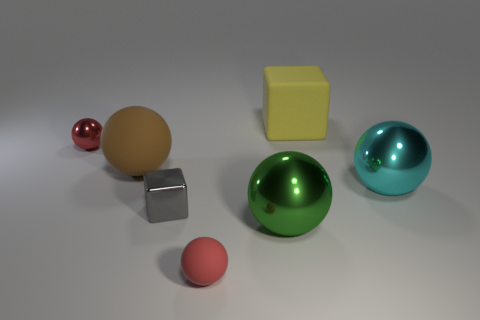Subtract all small metal spheres. How many spheres are left? 4 Subtract all yellow spheres. Subtract all blue cylinders. How many spheres are left? 5 Add 2 gray things. How many objects exist? 9 Subtract all cubes. How many objects are left? 5 Subtract 0 blue balls. How many objects are left? 7 Subtract all green metal blocks. Subtract all spheres. How many objects are left? 2 Add 5 metallic cubes. How many metallic cubes are left? 6 Add 3 large cubes. How many large cubes exist? 4 